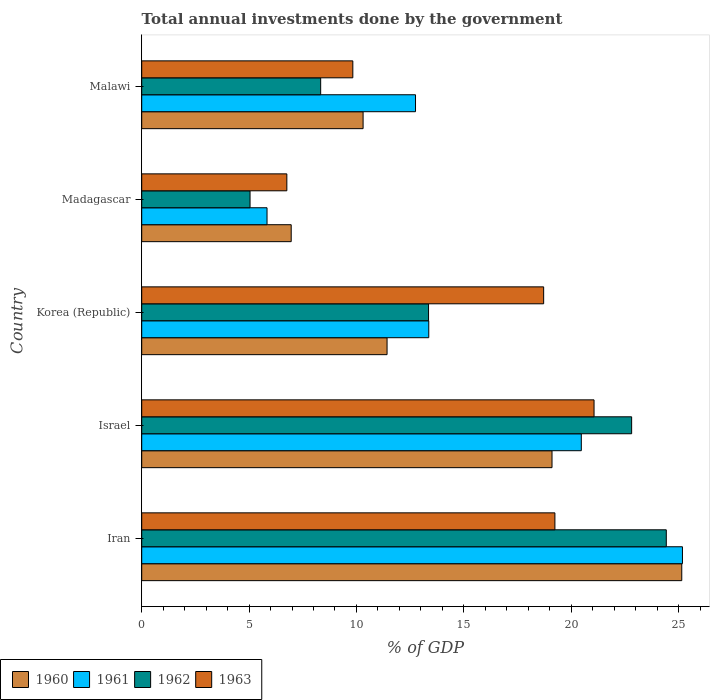Are the number of bars per tick equal to the number of legend labels?
Provide a succinct answer. Yes. How many bars are there on the 2nd tick from the bottom?
Make the answer very short. 4. What is the label of the 2nd group of bars from the top?
Your answer should be very brief. Madagascar. What is the total annual investments done by the government in 1961 in Malawi?
Provide a short and direct response. 12.75. Across all countries, what is the maximum total annual investments done by the government in 1961?
Make the answer very short. 25.18. Across all countries, what is the minimum total annual investments done by the government in 1963?
Your answer should be compact. 6.76. In which country was the total annual investments done by the government in 1962 maximum?
Your answer should be very brief. Iran. In which country was the total annual investments done by the government in 1963 minimum?
Make the answer very short. Madagascar. What is the total total annual investments done by the government in 1962 in the graph?
Your answer should be very brief. 73.98. What is the difference between the total annual investments done by the government in 1963 in Iran and that in Madagascar?
Offer a terse response. 12.48. What is the difference between the total annual investments done by the government in 1963 in Israel and the total annual investments done by the government in 1961 in Iran?
Offer a very short reply. -4.12. What is the average total annual investments done by the government in 1963 per country?
Your answer should be compact. 15.12. What is the difference between the total annual investments done by the government in 1960 and total annual investments done by the government in 1962 in Madagascar?
Provide a short and direct response. 1.92. In how many countries, is the total annual investments done by the government in 1960 greater than 18 %?
Offer a terse response. 2. What is the ratio of the total annual investments done by the government in 1963 in Iran to that in Korea (Republic)?
Give a very brief answer. 1.03. Is the difference between the total annual investments done by the government in 1960 in Iran and Korea (Republic) greater than the difference between the total annual investments done by the government in 1962 in Iran and Korea (Republic)?
Keep it short and to the point. Yes. What is the difference between the highest and the second highest total annual investments done by the government in 1961?
Make the answer very short. 4.71. What is the difference between the highest and the lowest total annual investments done by the government in 1962?
Offer a terse response. 19.38. Is the sum of the total annual investments done by the government in 1963 in Korea (Republic) and Malawi greater than the maximum total annual investments done by the government in 1962 across all countries?
Your answer should be compact. Yes. Is it the case that in every country, the sum of the total annual investments done by the government in 1962 and total annual investments done by the government in 1961 is greater than the sum of total annual investments done by the government in 1963 and total annual investments done by the government in 1960?
Ensure brevity in your answer.  No. What does the 3rd bar from the top in Iran represents?
Offer a very short reply. 1961. How many bars are there?
Ensure brevity in your answer.  20. Are all the bars in the graph horizontal?
Provide a short and direct response. Yes. How are the legend labels stacked?
Provide a short and direct response. Horizontal. What is the title of the graph?
Keep it short and to the point. Total annual investments done by the government. What is the label or title of the X-axis?
Ensure brevity in your answer.  % of GDP. What is the label or title of the Y-axis?
Make the answer very short. Country. What is the % of GDP of 1960 in Iran?
Ensure brevity in your answer.  25.15. What is the % of GDP in 1961 in Iran?
Your answer should be compact. 25.18. What is the % of GDP in 1962 in Iran?
Your response must be concise. 24.43. What is the % of GDP of 1963 in Iran?
Offer a very short reply. 19.24. What is the % of GDP of 1960 in Israel?
Your answer should be compact. 19.11. What is the % of GDP of 1961 in Israel?
Your answer should be compact. 20.47. What is the % of GDP in 1962 in Israel?
Give a very brief answer. 22.82. What is the % of GDP in 1963 in Israel?
Your response must be concise. 21.06. What is the % of GDP in 1960 in Korea (Republic)?
Ensure brevity in your answer.  11.43. What is the % of GDP of 1961 in Korea (Republic)?
Provide a succinct answer. 13.37. What is the % of GDP in 1962 in Korea (Republic)?
Your answer should be very brief. 13.36. What is the % of GDP of 1963 in Korea (Republic)?
Your answer should be very brief. 18.72. What is the % of GDP in 1960 in Madagascar?
Keep it short and to the point. 6.96. What is the % of GDP of 1961 in Madagascar?
Offer a very short reply. 5.84. What is the % of GDP of 1962 in Madagascar?
Provide a short and direct response. 5.04. What is the % of GDP in 1963 in Madagascar?
Provide a short and direct response. 6.76. What is the % of GDP of 1960 in Malawi?
Keep it short and to the point. 10.31. What is the % of GDP of 1961 in Malawi?
Make the answer very short. 12.75. What is the % of GDP in 1962 in Malawi?
Provide a succinct answer. 8.33. What is the % of GDP in 1963 in Malawi?
Ensure brevity in your answer.  9.83. Across all countries, what is the maximum % of GDP in 1960?
Give a very brief answer. 25.15. Across all countries, what is the maximum % of GDP of 1961?
Your answer should be very brief. 25.18. Across all countries, what is the maximum % of GDP in 1962?
Provide a short and direct response. 24.43. Across all countries, what is the maximum % of GDP of 1963?
Your answer should be compact. 21.06. Across all countries, what is the minimum % of GDP in 1960?
Your answer should be very brief. 6.96. Across all countries, what is the minimum % of GDP of 1961?
Your response must be concise. 5.84. Across all countries, what is the minimum % of GDP in 1962?
Your answer should be compact. 5.04. Across all countries, what is the minimum % of GDP in 1963?
Keep it short and to the point. 6.76. What is the total % of GDP of 1960 in the graph?
Your response must be concise. 72.95. What is the total % of GDP in 1961 in the graph?
Give a very brief answer. 77.61. What is the total % of GDP in 1962 in the graph?
Ensure brevity in your answer.  73.98. What is the total % of GDP in 1963 in the graph?
Provide a succinct answer. 75.61. What is the difference between the % of GDP of 1960 in Iran and that in Israel?
Ensure brevity in your answer.  6.04. What is the difference between the % of GDP in 1961 in Iran and that in Israel?
Give a very brief answer. 4.71. What is the difference between the % of GDP of 1962 in Iran and that in Israel?
Provide a short and direct response. 1.61. What is the difference between the % of GDP of 1963 in Iran and that in Israel?
Give a very brief answer. -1.82. What is the difference between the % of GDP in 1960 in Iran and that in Korea (Republic)?
Offer a terse response. 13.72. What is the difference between the % of GDP of 1961 in Iran and that in Korea (Republic)?
Ensure brevity in your answer.  11.81. What is the difference between the % of GDP of 1962 in Iran and that in Korea (Republic)?
Make the answer very short. 11.07. What is the difference between the % of GDP in 1963 in Iran and that in Korea (Republic)?
Ensure brevity in your answer.  0.52. What is the difference between the % of GDP in 1960 in Iran and that in Madagascar?
Provide a succinct answer. 18.19. What is the difference between the % of GDP in 1961 in Iran and that in Madagascar?
Offer a terse response. 19.35. What is the difference between the % of GDP of 1962 in Iran and that in Madagascar?
Provide a short and direct response. 19.38. What is the difference between the % of GDP in 1963 in Iran and that in Madagascar?
Give a very brief answer. 12.48. What is the difference between the % of GDP of 1960 in Iran and that in Malawi?
Your answer should be very brief. 14.84. What is the difference between the % of GDP of 1961 in Iran and that in Malawi?
Make the answer very short. 12.43. What is the difference between the % of GDP in 1962 in Iran and that in Malawi?
Your response must be concise. 16.1. What is the difference between the % of GDP of 1963 in Iran and that in Malawi?
Provide a succinct answer. 9.41. What is the difference between the % of GDP of 1960 in Israel and that in Korea (Republic)?
Make the answer very short. 7.68. What is the difference between the % of GDP of 1961 in Israel and that in Korea (Republic)?
Offer a terse response. 7.1. What is the difference between the % of GDP in 1962 in Israel and that in Korea (Republic)?
Keep it short and to the point. 9.46. What is the difference between the % of GDP of 1963 in Israel and that in Korea (Republic)?
Your answer should be compact. 2.35. What is the difference between the % of GDP of 1960 in Israel and that in Madagascar?
Provide a short and direct response. 12.15. What is the difference between the % of GDP in 1961 in Israel and that in Madagascar?
Provide a succinct answer. 14.64. What is the difference between the % of GDP in 1962 in Israel and that in Madagascar?
Keep it short and to the point. 17.77. What is the difference between the % of GDP in 1963 in Israel and that in Madagascar?
Offer a very short reply. 14.31. What is the difference between the % of GDP in 1960 in Israel and that in Malawi?
Give a very brief answer. 8.8. What is the difference between the % of GDP in 1961 in Israel and that in Malawi?
Make the answer very short. 7.72. What is the difference between the % of GDP of 1962 in Israel and that in Malawi?
Ensure brevity in your answer.  14.48. What is the difference between the % of GDP in 1963 in Israel and that in Malawi?
Make the answer very short. 11.23. What is the difference between the % of GDP in 1960 in Korea (Republic) and that in Madagascar?
Offer a terse response. 4.46. What is the difference between the % of GDP of 1961 in Korea (Republic) and that in Madagascar?
Offer a terse response. 7.53. What is the difference between the % of GDP of 1962 in Korea (Republic) and that in Madagascar?
Your answer should be very brief. 8.31. What is the difference between the % of GDP of 1963 in Korea (Republic) and that in Madagascar?
Keep it short and to the point. 11.96. What is the difference between the % of GDP of 1960 in Korea (Republic) and that in Malawi?
Ensure brevity in your answer.  1.12. What is the difference between the % of GDP in 1961 in Korea (Republic) and that in Malawi?
Provide a short and direct response. 0.62. What is the difference between the % of GDP in 1962 in Korea (Republic) and that in Malawi?
Provide a succinct answer. 5.02. What is the difference between the % of GDP of 1963 in Korea (Republic) and that in Malawi?
Keep it short and to the point. 8.89. What is the difference between the % of GDP of 1960 in Madagascar and that in Malawi?
Keep it short and to the point. -3.35. What is the difference between the % of GDP in 1961 in Madagascar and that in Malawi?
Your answer should be compact. -6.92. What is the difference between the % of GDP of 1962 in Madagascar and that in Malawi?
Provide a succinct answer. -3.29. What is the difference between the % of GDP of 1963 in Madagascar and that in Malawi?
Give a very brief answer. -3.07. What is the difference between the % of GDP of 1960 in Iran and the % of GDP of 1961 in Israel?
Make the answer very short. 4.68. What is the difference between the % of GDP in 1960 in Iran and the % of GDP in 1962 in Israel?
Provide a short and direct response. 2.33. What is the difference between the % of GDP of 1960 in Iran and the % of GDP of 1963 in Israel?
Your answer should be very brief. 4.08. What is the difference between the % of GDP of 1961 in Iran and the % of GDP of 1962 in Israel?
Ensure brevity in your answer.  2.37. What is the difference between the % of GDP of 1961 in Iran and the % of GDP of 1963 in Israel?
Keep it short and to the point. 4.12. What is the difference between the % of GDP of 1962 in Iran and the % of GDP of 1963 in Israel?
Keep it short and to the point. 3.36. What is the difference between the % of GDP in 1960 in Iran and the % of GDP in 1961 in Korea (Republic)?
Make the answer very short. 11.78. What is the difference between the % of GDP of 1960 in Iran and the % of GDP of 1962 in Korea (Republic)?
Provide a succinct answer. 11.79. What is the difference between the % of GDP in 1960 in Iran and the % of GDP in 1963 in Korea (Republic)?
Ensure brevity in your answer.  6.43. What is the difference between the % of GDP in 1961 in Iran and the % of GDP in 1962 in Korea (Republic)?
Give a very brief answer. 11.82. What is the difference between the % of GDP of 1961 in Iran and the % of GDP of 1963 in Korea (Republic)?
Your answer should be very brief. 6.46. What is the difference between the % of GDP in 1962 in Iran and the % of GDP in 1963 in Korea (Republic)?
Offer a very short reply. 5.71. What is the difference between the % of GDP of 1960 in Iran and the % of GDP of 1961 in Madagascar?
Keep it short and to the point. 19.31. What is the difference between the % of GDP of 1960 in Iran and the % of GDP of 1962 in Madagascar?
Offer a very short reply. 20.11. What is the difference between the % of GDP of 1960 in Iran and the % of GDP of 1963 in Madagascar?
Provide a short and direct response. 18.39. What is the difference between the % of GDP in 1961 in Iran and the % of GDP in 1962 in Madagascar?
Ensure brevity in your answer.  20.14. What is the difference between the % of GDP in 1961 in Iran and the % of GDP in 1963 in Madagascar?
Give a very brief answer. 18.42. What is the difference between the % of GDP of 1962 in Iran and the % of GDP of 1963 in Madagascar?
Provide a succinct answer. 17.67. What is the difference between the % of GDP in 1960 in Iran and the % of GDP in 1961 in Malawi?
Your answer should be compact. 12.4. What is the difference between the % of GDP of 1960 in Iran and the % of GDP of 1962 in Malawi?
Give a very brief answer. 16.82. What is the difference between the % of GDP of 1960 in Iran and the % of GDP of 1963 in Malawi?
Your response must be concise. 15.32. What is the difference between the % of GDP of 1961 in Iran and the % of GDP of 1962 in Malawi?
Make the answer very short. 16.85. What is the difference between the % of GDP of 1961 in Iran and the % of GDP of 1963 in Malawi?
Ensure brevity in your answer.  15.35. What is the difference between the % of GDP of 1962 in Iran and the % of GDP of 1963 in Malawi?
Provide a succinct answer. 14.6. What is the difference between the % of GDP in 1960 in Israel and the % of GDP in 1961 in Korea (Republic)?
Your answer should be very brief. 5.74. What is the difference between the % of GDP of 1960 in Israel and the % of GDP of 1962 in Korea (Republic)?
Provide a short and direct response. 5.75. What is the difference between the % of GDP of 1960 in Israel and the % of GDP of 1963 in Korea (Republic)?
Provide a short and direct response. 0.39. What is the difference between the % of GDP in 1961 in Israel and the % of GDP in 1962 in Korea (Republic)?
Provide a succinct answer. 7.11. What is the difference between the % of GDP in 1961 in Israel and the % of GDP in 1963 in Korea (Republic)?
Provide a short and direct response. 1.75. What is the difference between the % of GDP of 1962 in Israel and the % of GDP of 1963 in Korea (Republic)?
Keep it short and to the point. 4.1. What is the difference between the % of GDP in 1960 in Israel and the % of GDP in 1961 in Madagascar?
Keep it short and to the point. 13.27. What is the difference between the % of GDP of 1960 in Israel and the % of GDP of 1962 in Madagascar?
Provide a succinct answer. 14.06. What is the difference between the % of GDP in 1960 in Israel and the % of GDP in 1963 in Madagascar?
Make the answer very short. 12.35. What is the difference between the % of GDP of 1961 in Israel and the % of GDP of 1962 in Madagascar?
Offer a very short reply. 15.43. What is the difference between the % of GDP of 1961 in Israel and the % of GDP of 1963 in Madagascar?
Keep it short and to the point. 13.71. What is the difference between the % of GDP of 1962 in Israel and the % of GDP of 1963 in Madagascar?
Your answer should be very brief. 16.06. What is the difference between the % of GDP of 1960 in Israel and the % of GDP of 1961 in Malawi?
Your answer should be compact. 6.36. What is the difference between the % of GDP of 1960 in Israel and the % of GDP of 1962 in Malawi?
Your response must be concise. 10.77. What is the difference between the % of GDP of 1960 in Israel and the % of GDP of 1963 in Malawi?
Provide a succinct answer. 9.28. What is the difference between the % of GDP in 1961 in Israel and the % of GDP in 1962 in Malawi?
Provide a short and direct response. 12.14. What is the difference between the % of GDP in 1961 in Israel and the % of GDP in 1963 in Malawi?
Keep it short and to the point. 10.64. What is the difference between the % of GDP of 1962 in Israel and the % of GDP of 1963 in Malawi?
Provide a short and direct response. 12.98. What is the difference between the % of GDP of 1960 in Korea (Republic) and the % of GDP of 1961 in Madagascar?
Ensure brevity in your answer.  5.59. What is the difference between the % of GDP of 1960 in Korea (Republic) and the % of GDP of 1962 in Madagascar?
Offer a very short reply. 6.38. What is the difference between the % of GDP in 1960 in Korea (Republic) and the % of GDP in 1963 in Madagascar?
Offer a very short reply. 4.67. What is the difference between the % of GDP in 1961 in Korea (Republic) and the % of GDP in 1962 in Madagascar?
Offer a terse response. 8.32. What is the difference between the % of GDP in 1961 in Korea (Republic) and the % of GDP in 1963 in Madagascar?
Give a very brief answer. 6.61. What is the difference between the % of GDP of 1962 in Korea (Republic) and the % of GDP of 1963 in Madagascar?
Your answer should be compact. 6.6. What is the difference between the % of GDP of 1960 in Korea (Republic) and the % of GDP of 1961 in Malawi?
Make the answer very short. -1.33. What is the difference between the % of GDP of 1960 in Korea (Republic) and the % of GDP of 1962 in Malawi?
Provide a short and direct response. 3.09. What is the difference between the % of GDP in 1960 in Korea (Republic) and the % of GDP in 1963 in Malawi?
Your answer should be very brief. 1.59. What is the difference between the % of GDP of 1961 in Korea (Republic) and the % of GDP of 1962 in Malawi?
Your response must be concise. 5.03. What is the difference between the % of GDP of 1961 in Korea (Republic) and the % of GDP of 1963 in Malawi?
Offer a very short reply. 3.54. What is the difference between the % of GDP of 1962 in Korea (Republic) and the % of GDP of 1963 in Malawi?
Provide a succinct answer. 3.53. What is the difference between the % of GDP in 1960 in Madagascar and the % of GDP in 1961 in Malawi?
Your response must be concise. -5.79. What is the difference between the % of GDP in 1960 in Madagascar and the % of GDP in 1962 in Malawi?
Your response must be concise. -1.37. What is the difference between the % of GDP of 1960 in Madagascar and the % of GDP of 1963 in Malawi?
Your answer should be compact. -2.87. What is the difference between the % of GDP in 1961 in Madagascar and the % of GDP in 1962 in Malawi?
Make the answer very short. -2.5. What is the difference between the % of GDP of 1961 in Madagascar and the % of GDP of 1963 in Malawi?
Your answer should be very brief. -4. What is the difference between the % of GDP in 1962 in Madagascar and the % of GDP in 1963 in Malawi?
Offer a terse response. -4.79. What is the average % of GDP in 1960 per country?
Your response must be concise. 14.59. What is the average % of GDP in 1961 per country?
Keep it short and to the point. 15.52. What is the average % of GDP in 1962 per country?
Your response must be concise. 14.8. What is the average % of GDP in 1963 per country?
Your answer should be compact. 15.12. What is the difference between the % of GDP of 1960 and % of GDP of 1961 in Iran?
Keep it short and to the point. -0.03. What is the difference between the % of GDP in 1960 and % of GDP in 1962 in Iran?
Give a very brief answer. 0.72. What is the difference between the % of GDP in 1960 and % of GDP in 1963 in Iran?
Your answer should be compact. 5.91. What is the difference between the % of GDP in 1961 and % of GDP in 1962 in Iran?
Give a very brief answer. 0.75. What is the difference between the % of GDP in 1961 and % of GDP in 1963 in Iran?
Provide a succinct answer. 5.94. What is the difference between the % of GDP of 1962 and % of GDP of 1963 in Iran?
Provide a short and direct response. 5.19. What is the difference between the % of GDP in 1960 and % of GDP in 1961 in Israel?
Provide a succinct answer. -1.36. What is the difference between the % of GDP of 1960 and % of GDP of 1962 in Israel?
Provide a short and direct response. -3.71. What is the difference between the % of GDP of 1960 and % of GDP of 1963 in Israel?
Keep it short and to the point. -1.96. What is the difference between the % of GDP in 1961 and % of GDP in 1962 in Israel?
Make the answer very short. -2.34. What is the difference between the % of GDP in 1961 and % of GDP in 1963 in Israel?
Provide a succinct answer. -0.59. What is the difference between the % of GDP of 1962 and % of GDP of 1963 in Israel?
Give a very brief answer. 1.75. What is the difference between the % of GDP of 1960 and % of GDP of 1961 in Korea (Republic)?
Keep it short and to the point. -1.94. What is the difference between the % of GDP in 1960 and % of GDP in 1962 in Korea (Republic)?
Provide a succinct answer. -1.93. What is the difference between the % of GDP in 1960 and % of GDP in 1963 in Korea (Republic)?
Make the answer very short. -7.29. What is the difference between the % of GDP of 1961 and % of GDP of 1962 in Korea (Republic)?
Your answer should be compact. 0.01. What is the difference between the % of GDP of 1961 and % of GDP of 1963 in Korea (Republic)?
Keep it short and to the point. -5.35. What is the difference between the % of GDP in 1962 and % of GDP in 1963 in Korea (Republic)?
Your response must be concise. -5.36. What is the difference between the % of GDP of 1960 and % of GDP of 1961 in Madagascar?
Offer a terse response. 1.13. What is the difference between the % of GDP of 1960 and % of GDP of 1962 in Madagascar?
Offer a very short reply. 1.92. What is the difference between the % of GDP of 1960 and % of GDP of 1963 in Madagascar?
Provide a short and direct response. 0.2. What is the difference between the % of GDP of 1961 and % of GDP of 1962 in Madagascar?
Offer a terse response. 0.79. What is the difference between the % of GDP in 1961 and % of GDP in 1963 in Madagascar?
Provide a succinct answer. -0.92. What is the difference between the % of GDP of 1962 and % of GDP of 1963 in Madagascar?
Make the answer very short. -1.71. What is the difference between the % of GDP of 1960 and % of GDP of 1961 in Malawi?
Your answer should be very brief. -2.44. What is the difference between the % of GDP of 1960 and % of GDP of 1962 in Malawi?
Offer a very short reply. 1.98. What is the difference between the % of GDP in 1960 and % of GDP in 1963 in Malawi?
Provide a succinct answer. 0.48. What is the difference between the % of GDP of 1961 and % of GDP of 1962 in Malawi?
Make the answer very short. 4.42. What is the difference between the % of GDP of 1961 and % of GDP of 1963 in Malawi?
Provide a succinct answer. 2.92. What is the difference between the % of GDP of 1962 and % of GDP of 1963 in Malawi?
Offer a very short reply. -1.5. What is the ratio of the % of GDP of 1960 in Iran to that in Israel?
Your answer should be very brief. 1.32. What is the ratio of the % of GDP of 1961 in Iran to that in Israel?
Your response must be concise. 1.23. What is the ratio of the % of GDP in 1962 in Iran to that in Israel?
Offer a very short reply. 1.07. What is the ratio of the % of GDP of 1963 in Iran to that in Israel?
Offer a very short reply. 0.91. What is the ratio of the % of GDP in 1960 in Iran to that in Korea (Republic)?
Ensure brevity in your answer.  2.2. What is the ratio of the % of GDP in 1961 in Iran to that in Korea (Republic)?
Your response must be concise. 1.88. What is the ratio of the % of GDP of 1962 in Iran to that in Korea (Republic)?
Provide a short and direct response. 1.83. What is the ratio of the % of GDP of 1963 in Iran to that in Korea (Republic)?
Give a very brief answer. 1.03. What is the ratio of the % of GDP of 1960 in Iran to that in Madagascar?
Make the answer very short. 3.61. What is the ratio of the % of GDP of 1961 in Iran to that in Madagascar?
Offer a terse response. 4.32. What is the ratio of the % of GDP of 1962 in Iran to that in Madagascar?
Your response must be concise. 4.84. What is the ratio of the % of GDP in 1963 in Iran to that in Madagascar?
Provide a succinct answer. 2.85. What is the ratio of the % of GDP in 1960 in Iran to that in Malawi?
Give a very brief answer. 2.44. What is the ratio of the % of GDP in 1961 in Iran to that in Malawi?
Offer a very short reply. 1.97. What is the ratio of the % of GDP of 1962 in Iran to that in Malawi?
Offer a terse response. 2.93. What is the ratio of the % of GDP of 1963 in Iran to that in Malawi?
Your response must be concise. 1.96. What is the ratio of the % of GDP in 1960 in Israel to that in Korea (Republic)?
Provide a succinct answer. 1.67. What is the ratio of the % of GDP of 1961 in Israel to that in Korea (Republic)?
Ensure brevity in your answer.  1.53. What is the ratio of the % of GDP in 1962 in Israel to that in Korea (Republic)?
Provide a succinct answer. 1.71. What is the ratio of the % of GDP of 1963 in Israel to that in Korea (Republic)?
Provide a succinct answer. 1.13. What is the ratio of the % of GDP in 1960 in Israel to that in Madagascar?
Provide a succinct answer. 2.74. What is the ratio of the % of GDP in 1961 in Israel to that in Madagascar?
Make the answer very short. 3.51. What is the ratio of the % of GDP of 1962 in Israel to that in Madagascar?
Offer a very short reply. 4.52. What is the ratio of the % of GDP in 1963 in Israel to that in Madagascar?
Give a very brief answer. 3.12. What is the ratio of the % of GDP in 1960 in Israel to that in Malawi?
Provide a short and direct response. 1.85. What is the ratio of the % of GDP of 1961 in Israel to that in Malawi?
Your answer should be compact. 1.61. What is the ratio of the % of GDP in 1962 in Israel to that in Malawi?
Provide a short and direct response. 2.74. What is the ratio of the % of GDP in 1963 in Israel to that in Malawi?
Your answer should be very brief. 2.14. What is the ratio of the % of GDP in 1960 in Korea (Republic) to that in Madagascar?
Make the answer very short. 1.64. What is the ratio of the % of GDP in 1961 in Korea (Republic) to that in Madagascar?
Provide a succinct answer. 2.29. What is the ratio of the % of GDP in 1962 in Korea (Republic) to that in Madagascar?
Provide a succinct answer. 2.65. What is the ratio of the % of GDP in 1963 in Korea (Republic) to that in Madagascar?
Give a very brief answer. 2.77. What is the ratio of the % of GDP in 1960 in Korea (Republic) to that in Malawi?
Offer a very short reply. 1.11. What is the ratio of the % of GDP of 1961 in Korea (Republic) to that in Malawi?
Provide a succinct answer. 1.05. What is the ratio of the % of GDP in 1962 in Korea (Republic) to that in Malawi?
Your answer should be compact. 1.6. What is the ratio of the % of GDP in 1963 in Korea (Republic) to that in Malawi?
Provide a short and direct response. 1.9. What is the ratio of the % of GDP in 1960 in Madagascar to that in Malawi?
Your answer should be compact. 0.68. What is the ratio of the % of GDP in 1961 in Madagascar to that in Malawi?
Give a very brief answer. 0.46. What is the ratio of the % of GDP in 1962 in Madagascar to that in Malawi?
Ensure brevity in your answer.  0.61. What is the ratio of the % of GDP of 1963 in Madagascar to that in Malawi?
Make the answer very short. 0.69. What is the difference between the highest and the second highest % of GDP in 1960?
Provide a short and direct response. 6.04. What is the difference between the highest and the second highest % of GDP in 1961?
Your answer should be compact. 4.71. What is the difference between the highest and the second highest % of GDP in 1962?
Provide a succinct answer. 1.61. What is the difference between the highest and the second highest % of GDP in 1963?
Provide a succinct answer. 1.82. What is the difference between the highest and the lowest % of GDP in 1960?
Keep it short and to the point. 18.19. What is the difference between the highest and the lowest % of GDP in 1961?
Keep it short and to the point. 19.35. What is the difference between the highest and the lowest % of GDP of 1962?
Keep it short and to the point. 19.38. What is the difference between the highest and the lowest % of GDP in 1963?
Keep it short and to the point. 14.31. 